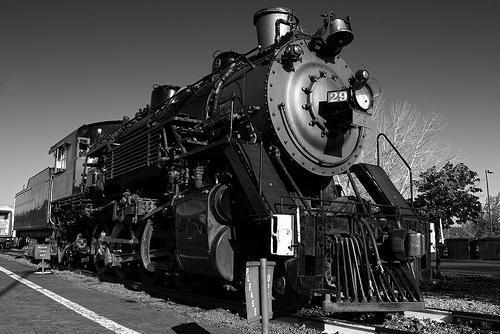How many trains are there?
Give a very brief answer. 1. 